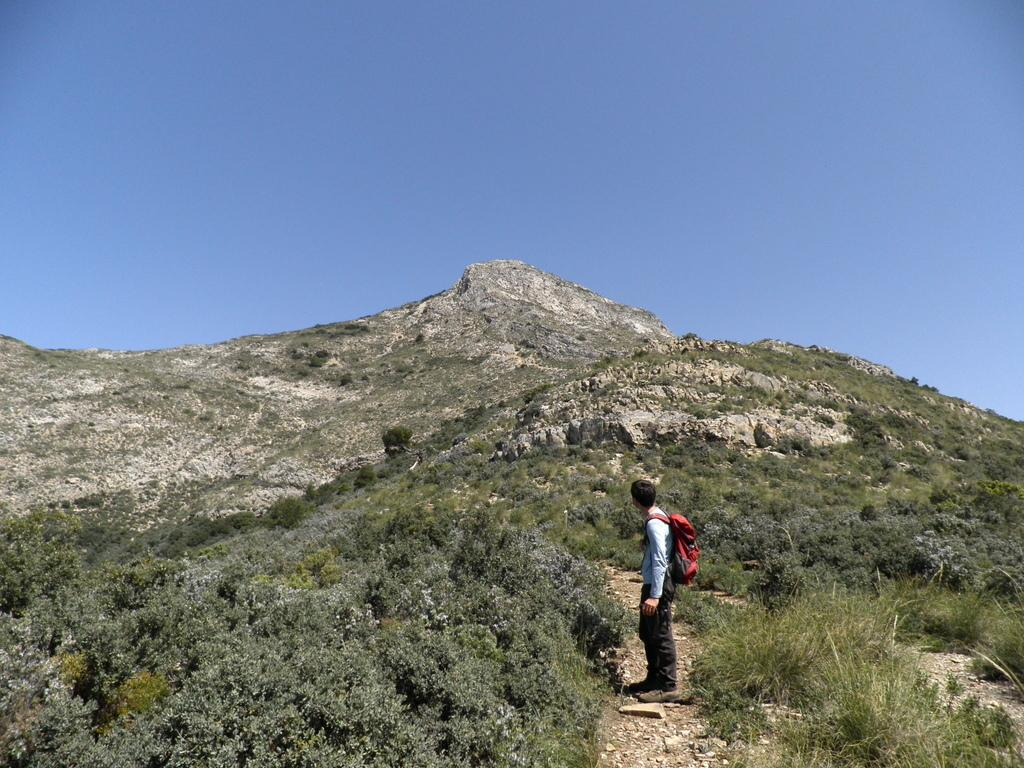What type of location is depicted in the image? The image appears to depict a hill station. What can be seen on the hill in the image? A man is standing on a hill. What is the man wearing in the image? The man is wearing a red color bag. What can be seen in the background of the image? There are a lot of trees and a mountain in the background, as well as the sky. What type of treatment is the man's grandmother receiving in the image? There is no mention of a grandmother or any treatment in the image; it only depicts a man standing on a hill with a red color bag. 